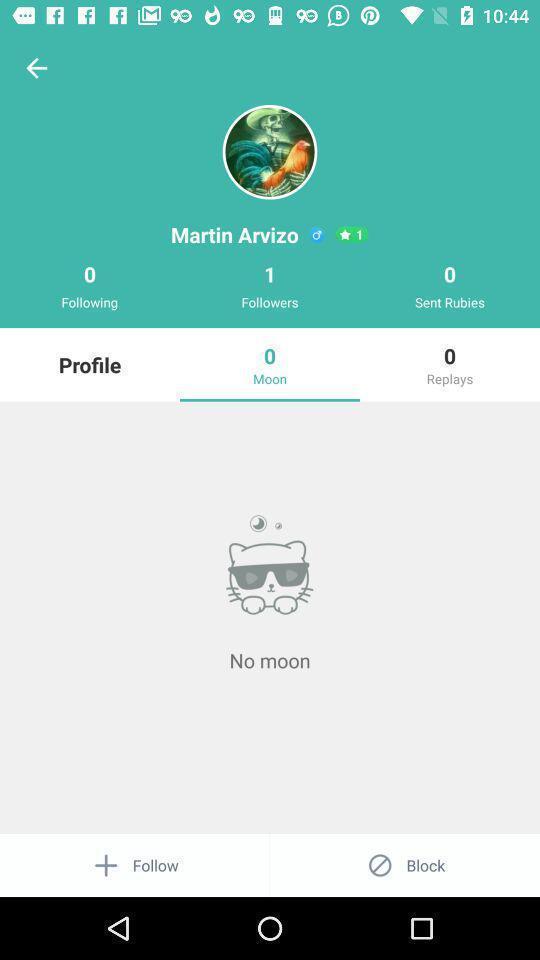Describe the key features of this screenshot. Screen shows profile details in an chat application. 